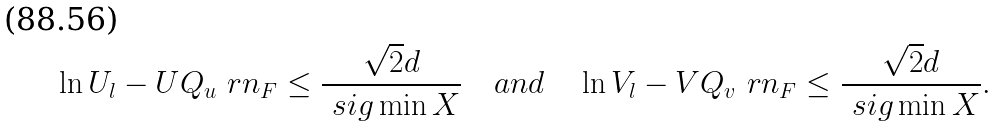Convert formula to latex. <formula><loc_0><loc_0><loc_500><loc_500>\ln U _ { l } - U Q _ { u } \ r n _ { F } \leq \frac { \sqrt { 2 } d } { \ s i g \min { X } } \quad a n d \quad \ln V _ { l } - V Q _ { v } \ r n _ { F } \leq \frac { \sqrt { 2 } d } { \ s i g \min { X } } .</formula> 